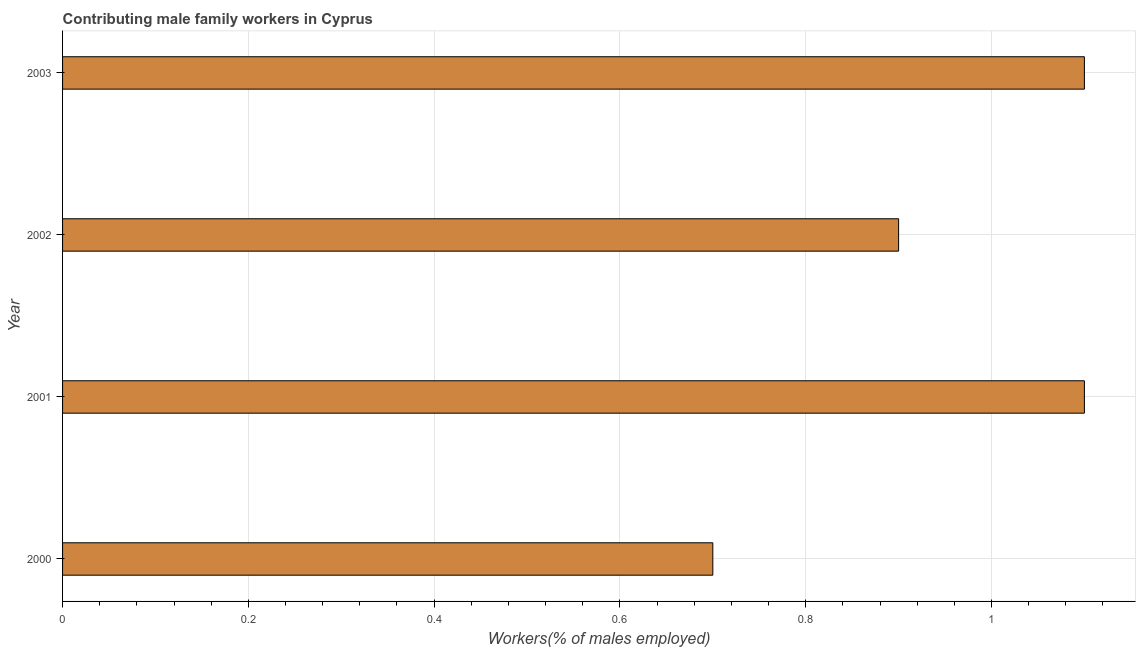Does the graph contain any zero values?
Ensure brevity in your answer.  No. What is the title of the graph?
Give a very brief answer. Contributing male family workers in Cyprus. What is the label or title of the X-axis?
Make the answer very short. Workers(% of males employed). What is the contributing male family workers in 2000?
Ensure brevity in your answer.  0.7. Across all years, what is the maximum contributing male family workers?
Offer a terse response. 1.1. Across all years, what is the minimum contributing male family workers?
Offer a terse response. 0.7. In which year was the contributing male family workers maximum?
Give a very brief answer. 2001. In which year was the contributing male family workers minimum?
Your answer should be very brief. 2000. What is the sum of the contributing male family workers?
Provide a succinct answer. 3.8. What is the difference between the contributing male family workers in 2000 and 2003?
Provide a succinct answer. -0.4. What is the median contributing male family workers?
Offer a terse response. 1. Do a majority of the years between 2002 and 2000 (inclusive) have contributing male family workers greater than 0.28 %?
Your answer should be very brief. Yes. What is the ratio of the contributing male family workers in 2001 to that in 2002?
Your answer should be compact. 1.22. Is the sum of the contributing male family workers in 2000 and 2001 greater than the maximum contributing male family workers across all years?
Keep it short and to the point. Yes. What is the difference between two consecutive major ticks on the X-axis?
Provide a succinct answer. 0.2. What is the Workers(% of males employed) in 2000?
Provide a short and direct response. 0.7. What is the Workers(% of males employed) of 2001?
Your answer should be very brief. 1.1. What is the Workers(% of males employed) in 2002?
Provide a short and direct response. 0.9. What is the Workers(% of males employed) of 2003?
Provide a short and direct response. 1.1. What is the difference between the Workers(% of males employed) in 2000 and 2001?
Ensure brevity in your answer.  -0.4. What is the difference between the Workers(% of males employed) in 2000 and 2002?
Offer a terse response. -0.2. What is the difference between the Workers(% of males employed) in 2000 and 2003?
Your answer should be compact. -0.4. What is the difference between the Workers(% of males employed) in 2001 and 2002?
Your response must be concise. 0.2. What is the difference between the Workers(% of males employed) in 2001 and 2003?
Ensure brevity in your answer.  0. What is the difference between the Workers(% of males employed) in 2002 and 2003?
Provide a short and direct response. -0.2. What is the ratio of the Workers(% of males employed) in 2000 to that in 2001?
Your response must be concise. 0.64. What is the ratio of the Workers(% of males employed) in 2000 to that in 2002?
Provide a succinct answer. 0.78. What is the ratio of the Workers(% of males employed) in 2000 to that in 2003?
Ensure brevity in your answer.  0.64. What is the ratio of the Workers(% of males employed) in 2001 to that in 2002?
Provide a succinct answer. 1.22. What is the ratio of the Workers(% of males employed) in 2002 to that in 2003?
Offer a terse response. 0.82. 